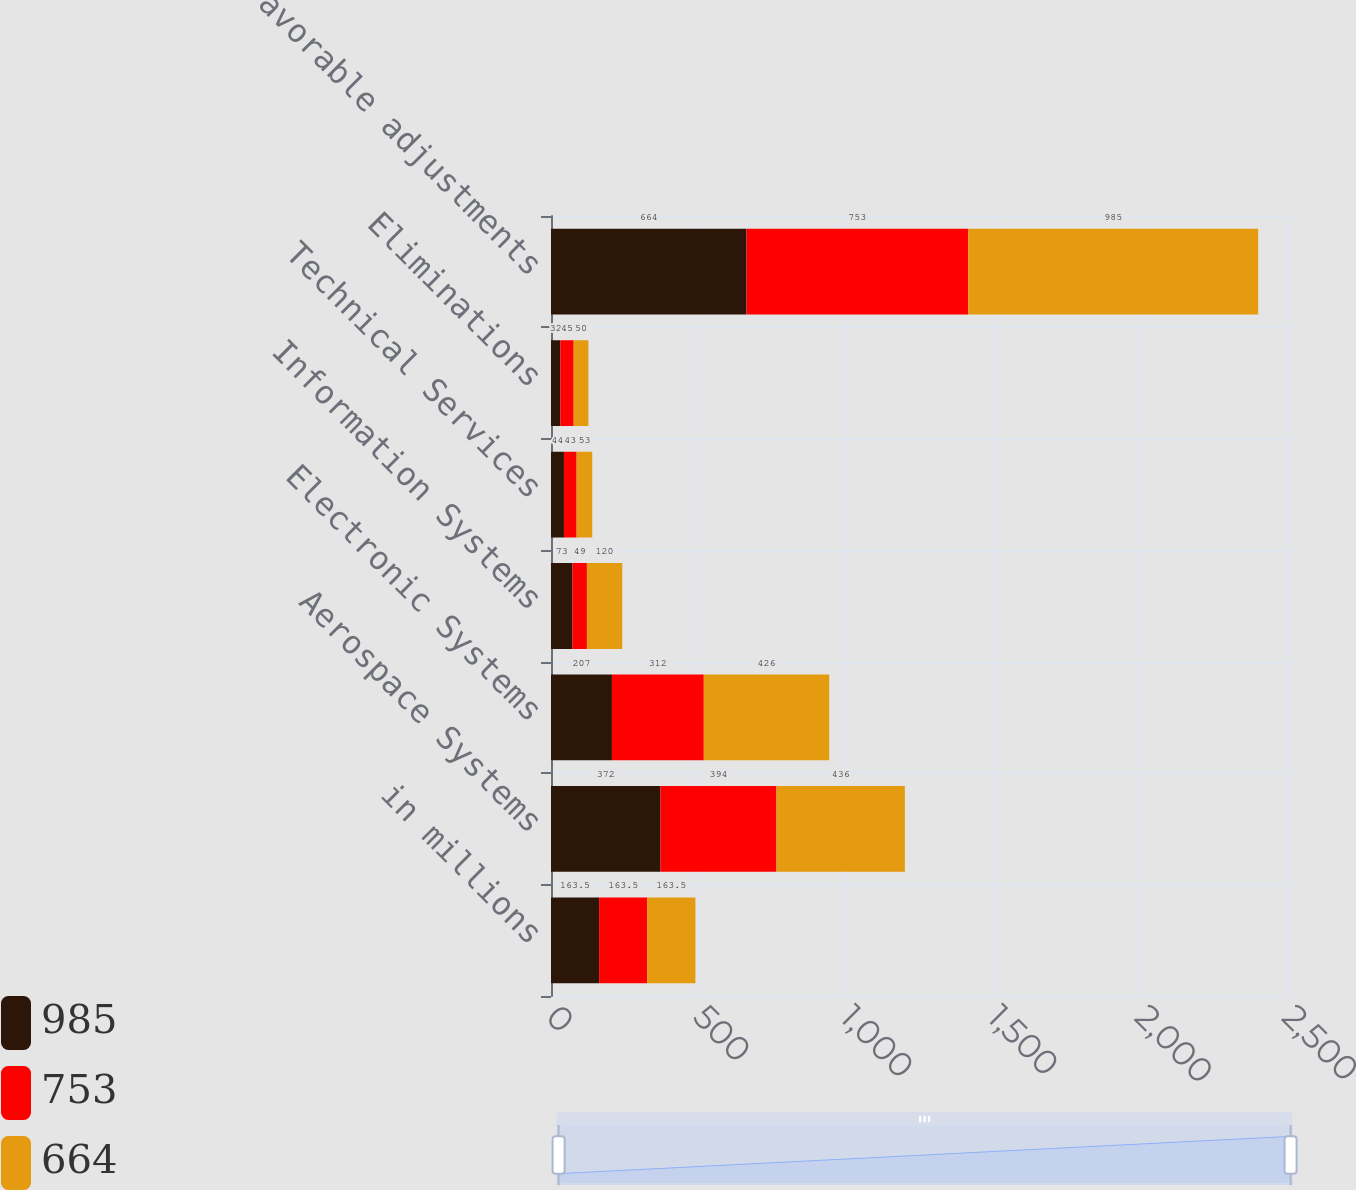Convert chart. <chart><loc_0><loc_0><loc_500><loc_500><stacked_bar_chart><ecel><fcel>in millions<fcel>Aerospace Systems<fcel>Electronic Systems<fcel>Information Systems<fcel>Technical Services<fcel>Eliminations<fcel>Net favorable adjustments<nl><fcel>985<fcel>163.5<fcel>372<fcel>207<fcel>73<fcel>44<fcel>32<fcel>664<nl><fcel>753<fcel>163.5<fcel>394<fcel>312<fcel>49<fcel>43<fcel>45<fcel>753<nl><fcel>664<fcel>163.5<fcel>436<fcel>426<fcel>120<fcel>53<fcel>50<fcel>985<nl></chart> 